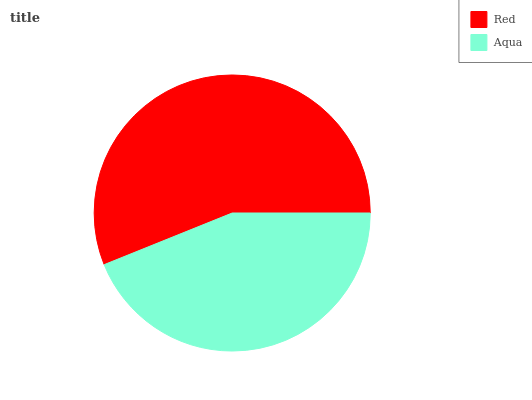Is Aqua the minimum?
Answer yes or no. Yes. Is Red the maximum?
Answer yes or no. Yes. Is Aqua the maximum?
Answer yes or no. No. Is Red greater than Aqua?
Answer yes or no. Yes. Is Aqua less than Red?
Answer yes or no. Yes. Is Aqua greater than Red?
Answer yes or no. No. Is Red less than Aqua?
Answer yes or no. No. Is Red the high median?
Answer yes or no. Yes. Is Aqua the low median?
Answer yes or no. Yes. Is Aqua the high median?
Answer yes or no. No. Is Red the low median?
Answer yes or no. No. 